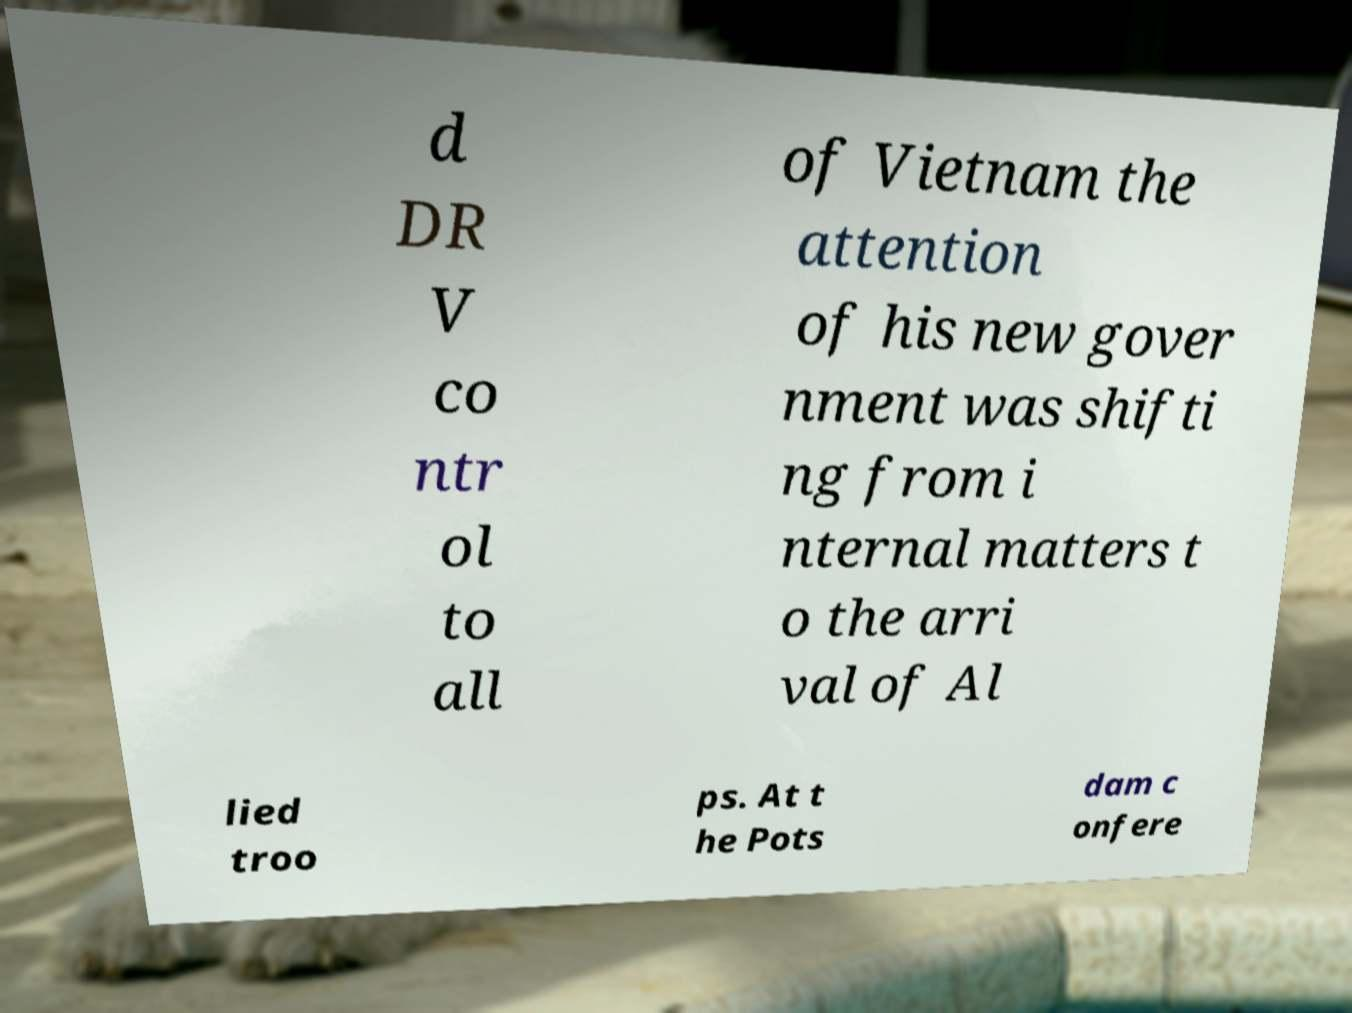Could you extract and type out the text from this image? d DR V co ntr ol to all of Vietnam the attention of his new gover nment was shifti ng from i nternal matters t o the arri val of Al lied troo ps. At t he Pots dam c onfere 